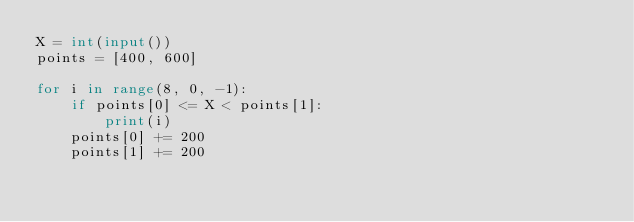Convert code to text. <code><loc_0><loc_0><loc_500><loc_500><_Python_>X = int(input())
points = [400, 600]

for i in range(8, 0, -1):
    if points[0] <= X < points[1]:
        print(i)
    points[0] += 200
    points[1] += 200</code> 